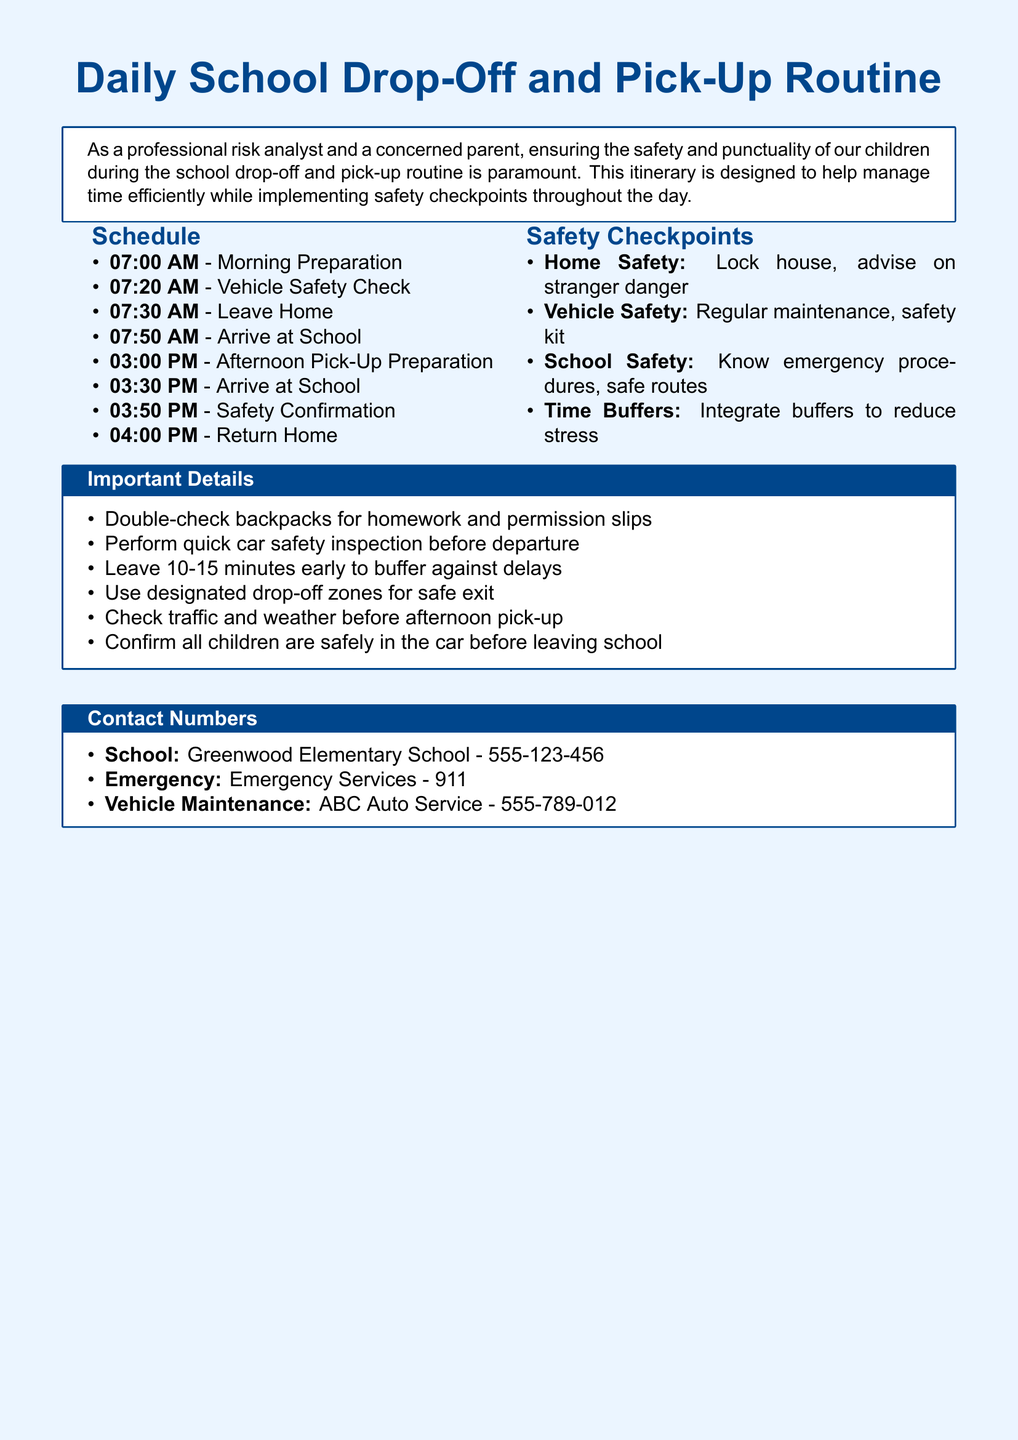what time does morning preparation start? The schedule indicates that morning preparation starts at 07:00 AM.
Answer: 07:00 AM how many safety checkpoints are listed? The document includes four safety checkpoints in the corresponding section.
Answer: 4 what should be double-checked before leaving home? The important details section states to double-check backpacks for homework and permission slips.
Answer: backpacks what is the emergency services contact number? The contact numbers section lists the emergency services number as 911.
Answer: 911 what is the time buffer suggested before leaving? The itinerary advises leaving 10-15 minutes early to buffer against delays.
Answer: 10-15 minutes what is the vehicle safety check time? According to the schedule, the vehicle safety check takes place at 07:20 AM.
Answer: 07:20 AM what is advised regarding car safety before departure? The important details section mentions performing a quick car safety inspection before departure.
Answer: car safety inspection which school is mentioned in the document? The contact numbers section mentions Greenwood Elementary School.
Answer: Greenwood Elementary School 